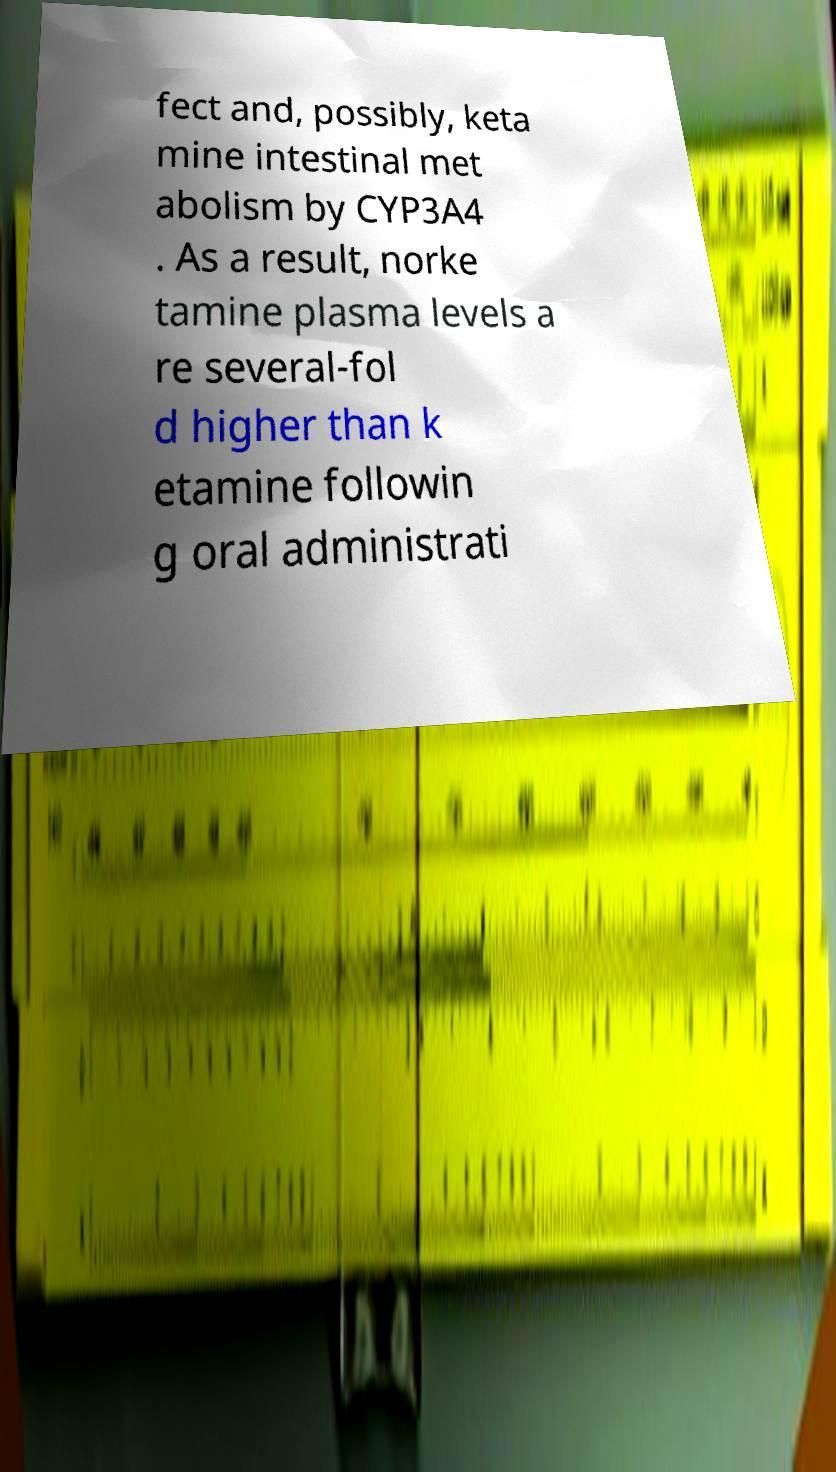Please identify and transcribe the text found in this image. fect and, possibly, keta mine intestinal met abolism by CYP3A4 . As a result, norke tamine plasma levels a re several-fol d higher than k etamine followin g oral administrati 